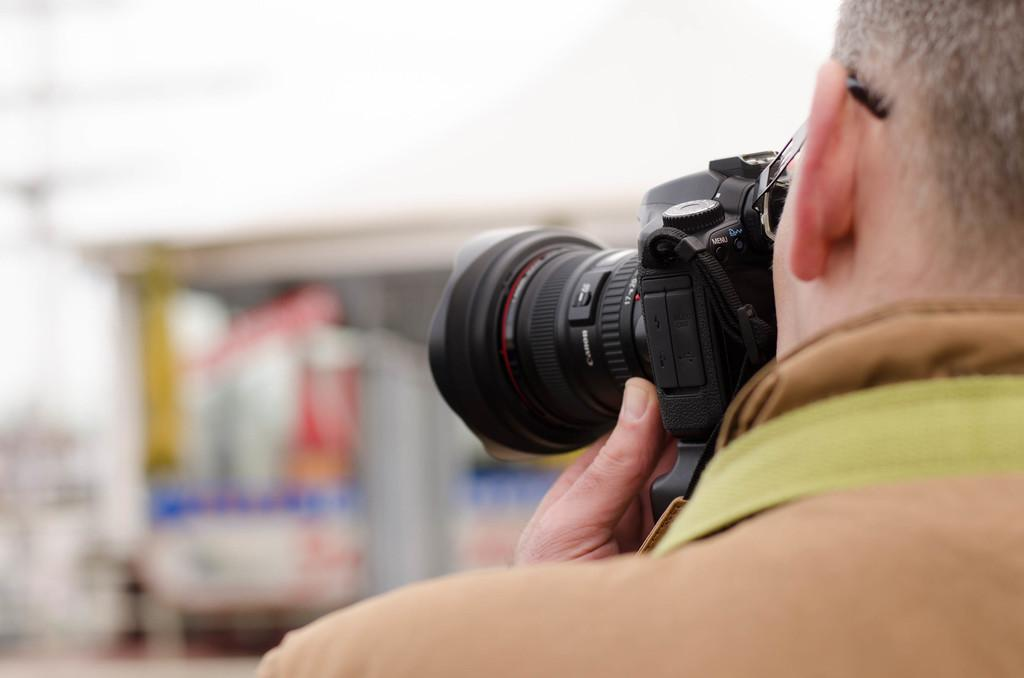Who is present on the right hand side of the image? There is a person on the right hand side of the image. What is the person wearing? The person is wearing a brown color shirt. What is the person holding in the image? The person is holding a camera. What is the person doing with the camera? The person is capturing a scenery in front of him. What type of creature can be seen hiding behind the person in the image? There is no creature present in the image; it only features a person holding a camera and capturing a scenery. 